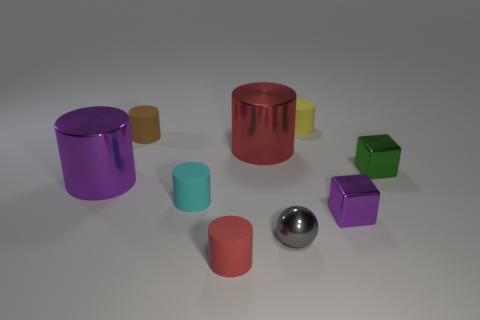How many things are metallic blocks or matte things that are in front of the large purple object?
Your answer should be very brief. 4. Is the material of the cyan cylinder the same as the yellow thing?
Provide a short and direct response. Yes. Are there the same number of metal cubes left of the tiny green metallic thing and matte cylinders behind the cyan cylinder?
Provide a short and direct response. No. What number of cyan things are in front of the purple metallic block?
Your answer should be compact. 0. What number of things are gray things or large brown matte balls?
Provide a succinct answer. 1. How many purple metallic things have the same size as the yellow matte object?
Provide a short and direct response. 1. There is a large thing behind the purple object on the left side of the red metal cylinder; what shape is it?
Your answer should be very brief. Cylinder. Is the number of big yellow things less than the number of brown objects?
Keep it short and to the point. Yes. There is a large shiny thing on the left side of the cyan object; what is its color?
Make the answer very short. Purple. What is the material of the thing that is right of the yellow rubber thing and in front of the cyan matte thing?
Ensure brevity in your answer.  Metal. 